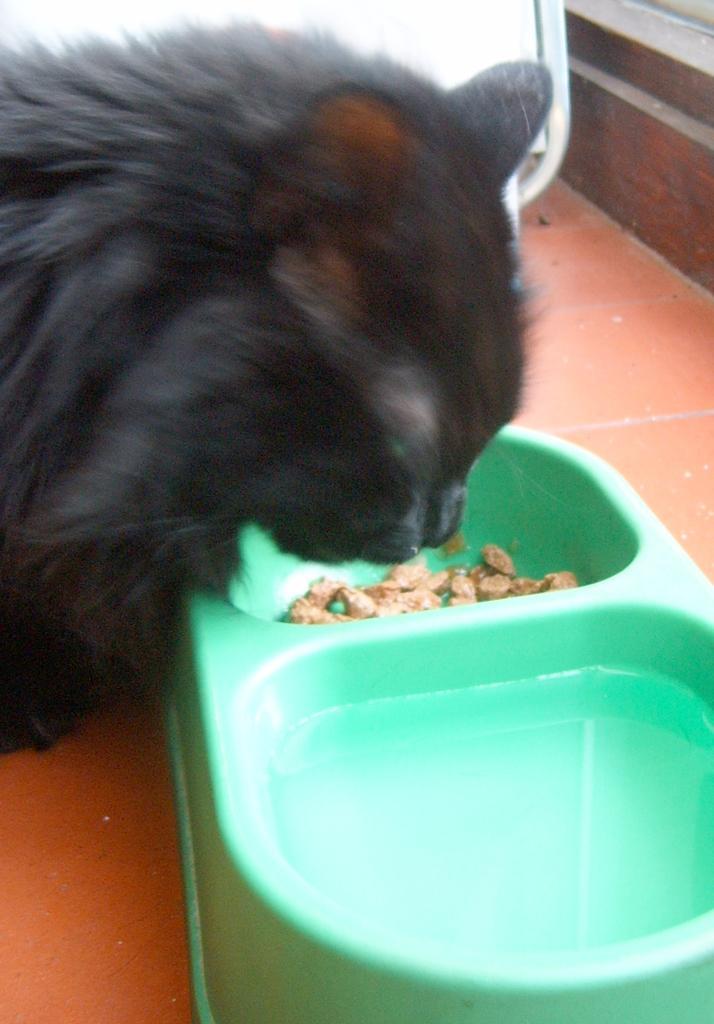Can you describe this image briefly? In this picture we can see a black color cat eating something, there is a plastic bowl here, it is of green color. 